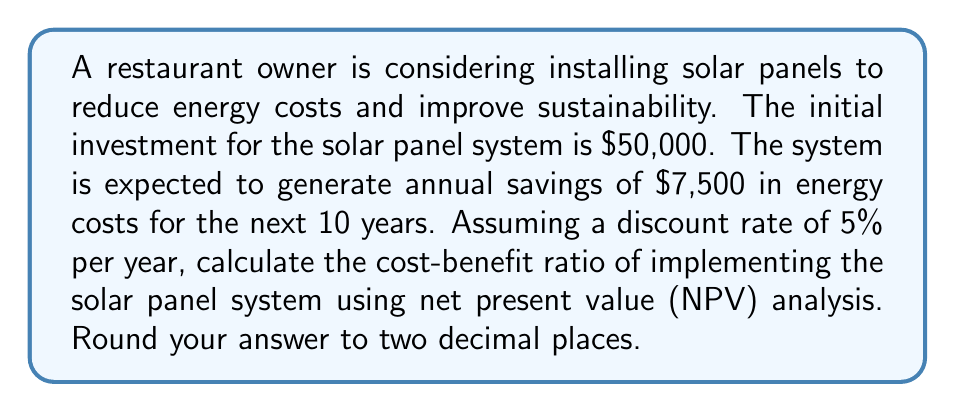Help me with this question. To calculate the cost-benefit ratio using NPV analysis, we need to follow these steps:

1. Calculate the NPV of the benefits (energy cost savings)
2. Calculate the NPV of the costs (initial investment)
3. Divide the NPV of benefits by the NPV of costs

Step 1: Calculate the NPV of benefits

The NPV of benefits is the present value of the future cash flows (energy savings) discounted at the given rate. We use the following formula:

$$ NPV_{benefits} = \sum_{t=1}^{n} \frac{CF_t}{(1+r)^t} $$

Where:
$CF_t$ = Cash flow at time t (annual energy savings)
$r$ = Discount rate
$n$ = Number of years

For our case:
$CF_t = \$7,500$ (constant for all years)
$r = 5\% = 0.05$
$n = 10$ years

$$ NPV_{benefits} = \sum_{t=1}^{10} \frac{7500}{(1+0.05)^t} $$

Using a financial calculator or spreadsheet, we get:

$$ NPV_{benefits} = \$57,921.90 $$

Step 2: Calculate the NPV of costs

The NPV of costs is simply the initial investment, as it occurs at time 0:

$$ NPV_{costs} = \$50,000 $$

Step 3: Calculate the cost-benefit ratio

The cost-benefit ratio is calculated by dividing the NPV of benefits by the NPV of costs:

$$ Cost-Benefit Ratio = \frac{NPV_{benefits}}{NPV_{costs}} = \frac{57,921.90}{50,000} = 1.16 $$

Rounded to two decimal places, we get 1.16.
Answer: 1.16 